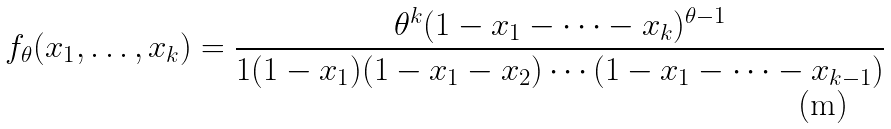Convert formula to latex. <formula><loc_0><loc_0><loc_500><loc_500>f _ { \theta } ( x _ { 1 } , \dots , x _ { k } ) = \frac { \theta ^ { k } ( 1 - x _ { 1 } - \cdots - x _ { k } ) ^ { \theta - 1 } } { 1 ( 1 - x _ { 1 } ) ( 1 - x _ { 1 } - x _ { 2 } ) \cdots ( 1 - x _ { 1 } - \cdots - x _ { k - 1 } ) }</formula> 